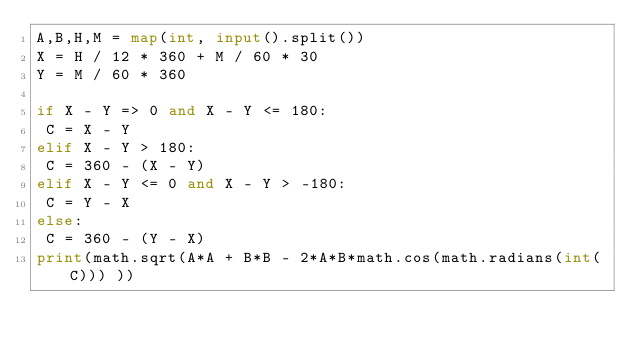Convert code to text. <code><loc_0><loc_0><loc_500><loc_500><_Python_>A,B,H,M = map(int, input().split())
X = H / 12 * 360 + M / 60 * 30
Y = M / 60 * 360 

if X - Y => 0 and X - Y <= 180:
 C = X - Y
elif X - Y > 180:
 C = 360 - (X - Y)
elif X - Y <= 0 and X - Y > -180:
 C = Y - X
else:
 C = 360 - (Y - X)
print(math.sqrt(A*A + B*B - 2*A*B*math.cos(math.radians(int(C))) ))
</code> 